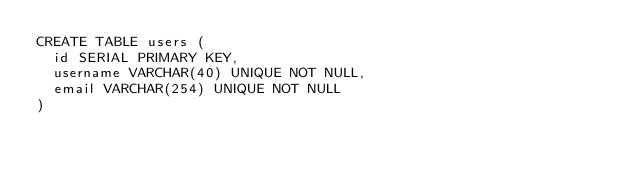<code> <loc_0><loc_0><loc_500><loc_500><_SQL_>CREATE TABLE users (
  id SERIAL PRIMARY KEY,
  username VARCHAR(40) UNIQUE NOT NULL,
  email VARCHAR(254) UNIQUE NOT NULL
)
</code> 